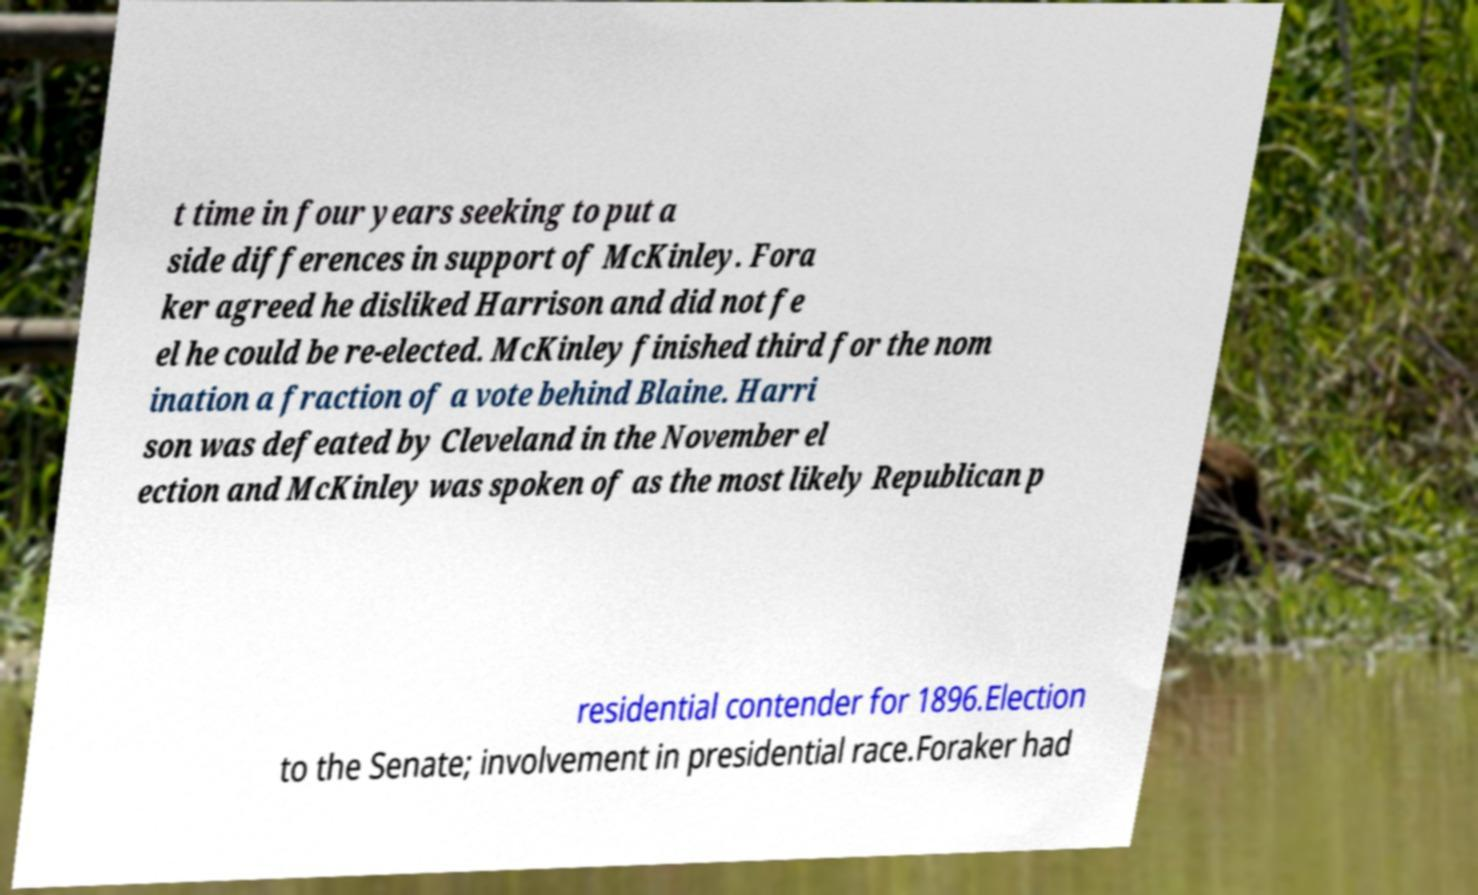Could you assist in decoding the text presented in this image and type it out clearly? t time in four years seeking to put a side differences in support of McKinley. Fora ker agreed he disliked Harrison and did not fe el he could be re-elected. McKinley finished third for the nom ination a fraction of a vote behind Blaine. Harri son was defeated by Cleveland in the November el ection and McKinley was spoken of as the most likely Republican p residential contender for 1896.Election to the Senate; involvement in presidential race.Foraker had 